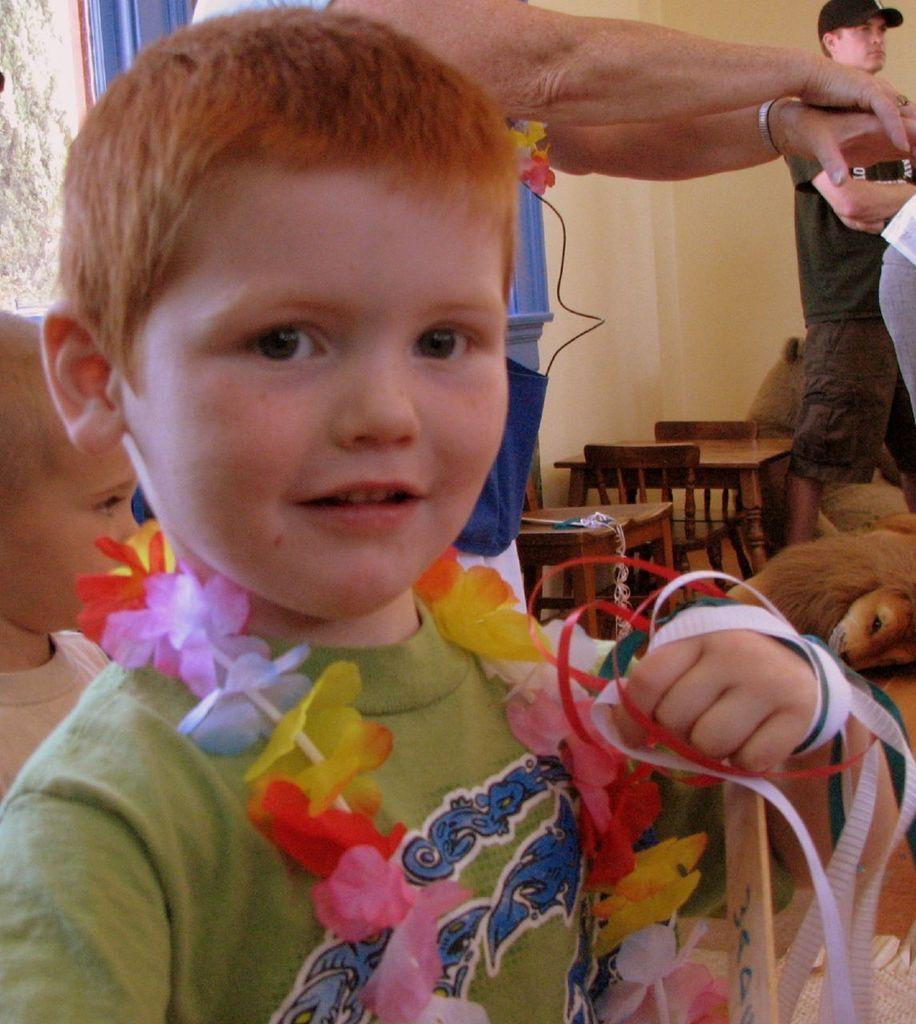What is the main subject of the image? There is a boy standing in the image. What type of furniture is visible in the image? There are tables and chairs in the image. Can you describe another person in the image? There is a person standing in the image. What type of living creature is present in the image? There is an animal in the image. What type of tin can be seen being used as a spade in the image? There is no tin or spade present in the image. What type of leather is visible on the animal in the image? There is no leather visible on the animal in the image. 